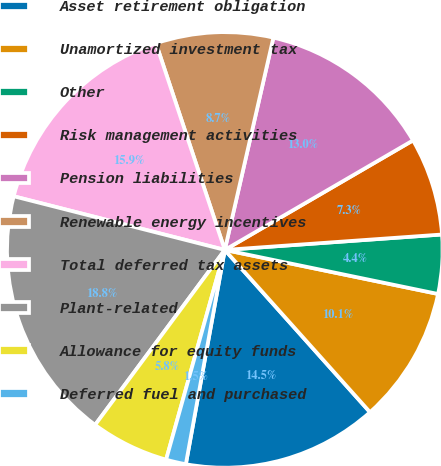Convert chart to OTSL. <chart><loc_0><loc_0><loc_500><loc_500><pie_chart><fcel>Asset retirement obligation<fcel>Unamortized investment tax<fcel>Other<fcel>Risk management activities<fcel>Pension liabilities<fcel>Renewable energy incentives<fcel>Total deferred tax assets<fcel>Plant-related<fcel>Allowance for equity funds<fcel>Deferred fuel and purchased<nl><fcel>14.48%<fcel>10.14%<fcel>4.37%<fcel>7.26%<fcel>13.03%<fcel>8.7%<fcel>15.92%<fcel>18.81%<fcel>5.81%<fcel>1.48%<nl></chart> 